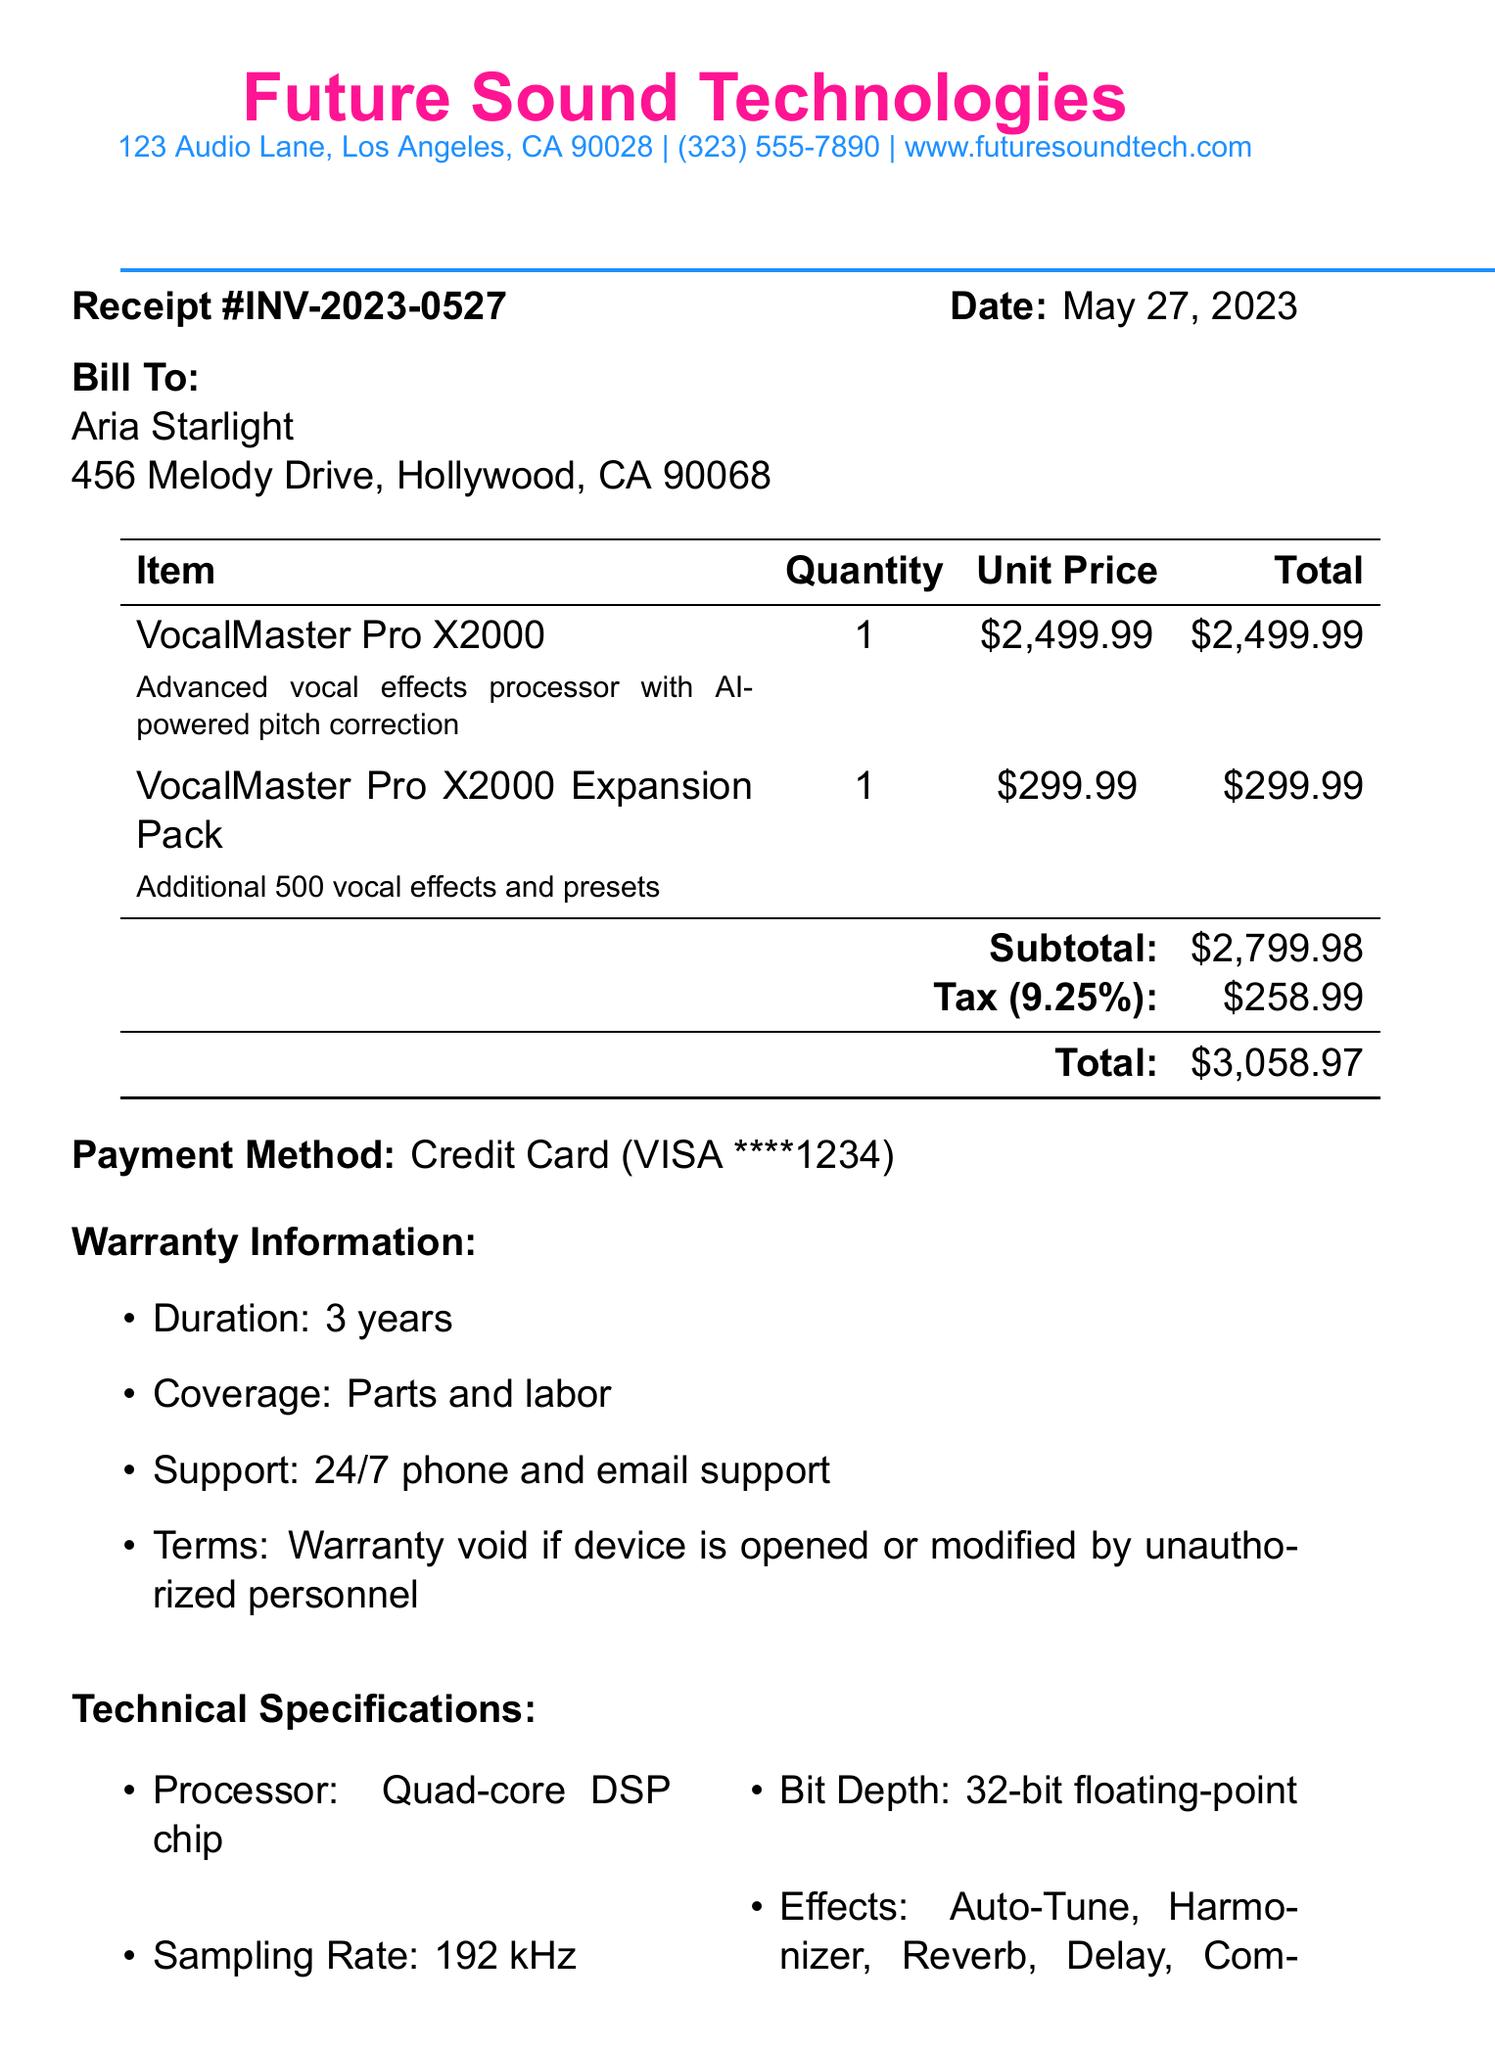What is the receipt number? The receipt number is indicated prominently at the top of the document.
Answer: INV-2023-0527 What is the total amount? The total amount is calculated by adding the subtotal and tax, shown clearly at the bottom of the item list.
Answer: $3,058.97 Who is the vendor? The vendor's name is listed in the header section of the receipt document.
Answer: Future Sound Technologies What is the duration of the warranty? The warranty information section specifies the duration of coverage of the product purchased.
Answer: 3 years What payment method was used? The payment method is mentioned below the total amount in the document.
Answer: Credit Card (VISA ****1234) How many user presets can the VocalMaster Pro X2000 store? The technical specifications section details the storage capacity of user presets for the product.
Answer: 500 user presets What is included in the expansion pack? The description of the expansion pack provides information on its contents.
Answer: Additional 500 vocal effects and presets What is the weight of the VocalMaster Pro X2000? The technical specifications include the weight of the product, providing a physical descriptor.
Answer: 8.5 lbs What display size does the device have? The specifications section mentions the size of the display for the vocal effects processor.
Answer: 7-inch color touchscreen 